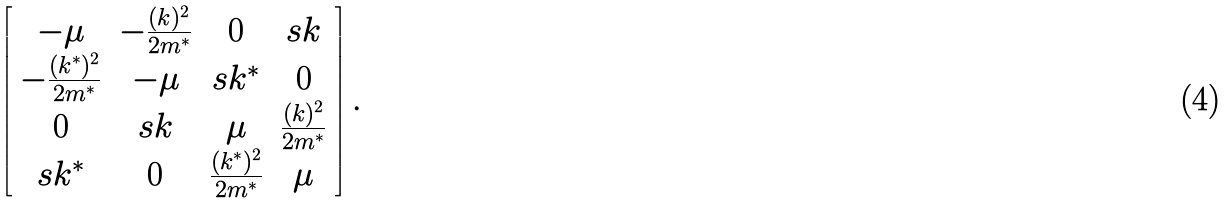Convert formula to latex. <formula><loc_0><loc_0><loc_500><loc_500>\left [ \begin{array} { c c c c } - \mu & - \frac { ( k ) ^ { 2 } } { 2 m ^ { * } } & 0 & s k \\ - \frac { ( k ^ { * } ) ^ { 2 } } { 2 m ^ { * } } & - \mu & s k ^ { * } & 0 \\ 0 & s k & \mu & \frac { ( k ) ^ { 2 } } { 2 m ^ { * } } \\ s k ^ { * } & 0 & \frac { ( k ^ { * } ) ^ { 2 } } { 2 m ^ { * } } & \mu \end{array} \right ] .</formula> 